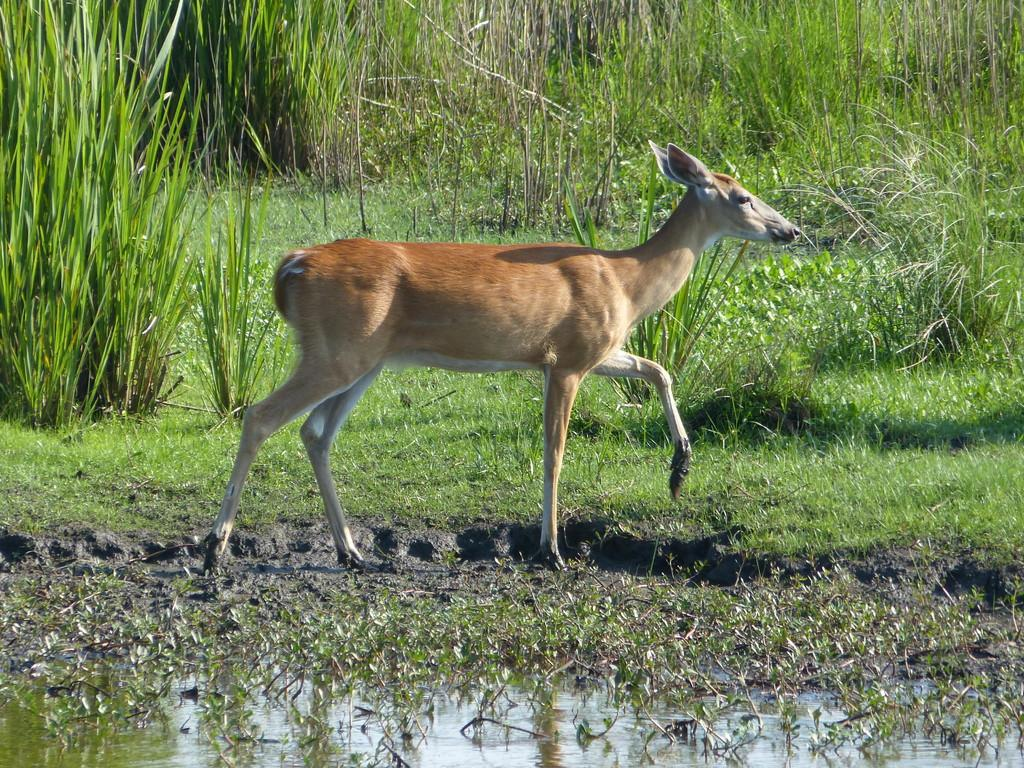What is in the mug that is visible in the image? There is beer in a mug in the image. What type of natural environment is visible in the image? There is grass and water visible in the image. What type of vegetation is present in the image? There are plants in the image. What type of mist can be seen surrounding the plants in the image? There is no mist present in the image; only grass, water, and plants are visible. 